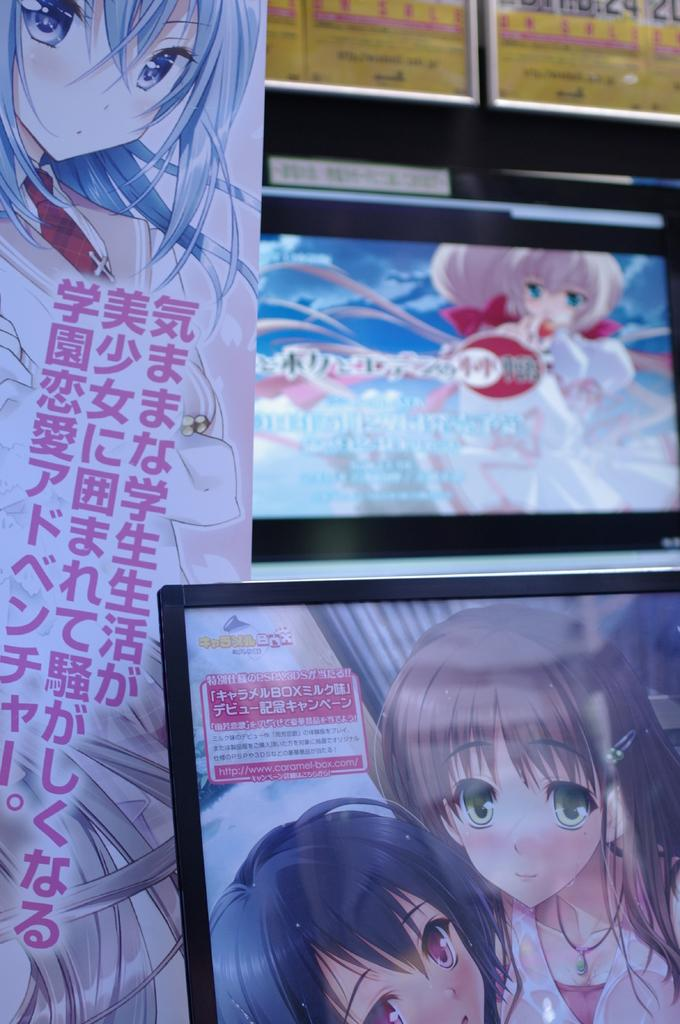What is the main subject in the center of the image? There are laptops in the center of the image. What else can be seen in the image besides the laptops? There is a banner in the image, and cartoon images are visible on the laptop screens. What is the background of the image? There is a wall in the background of the image. Where is the zoo located in the image? There is no zoo present in the image. What type of account is being used to access the laptops in the image? The image does not provide information about the type of account being used to access the laptops. 